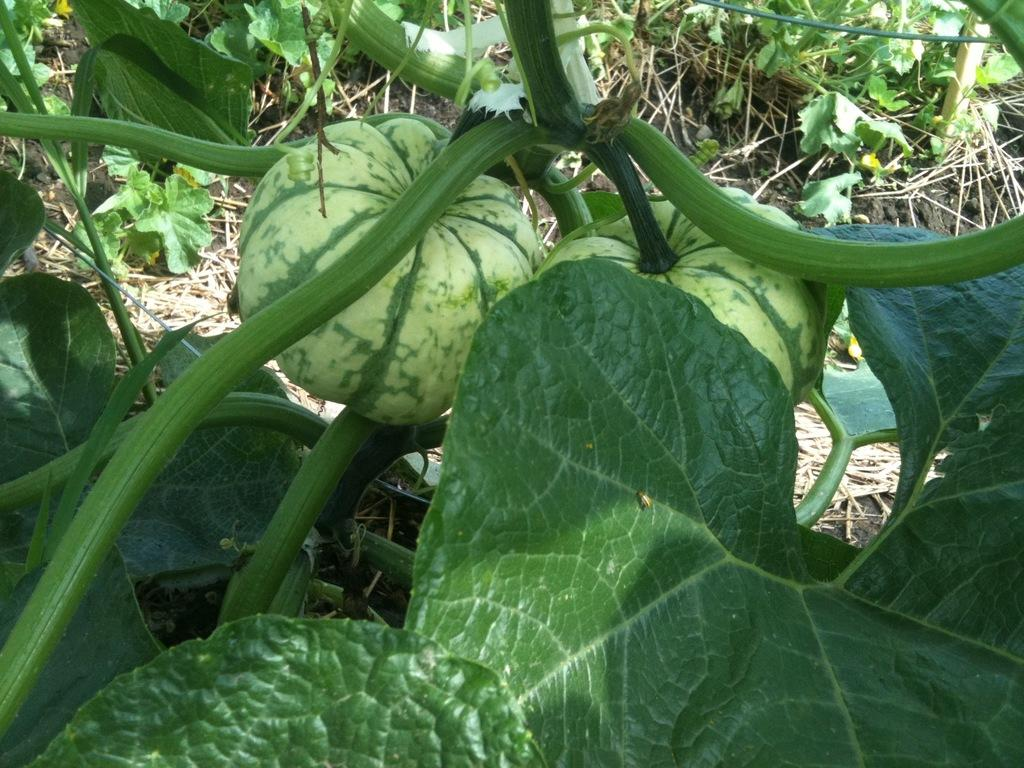What type of plants can be seen in the image? There are pumpkin plants in the image. Where are the pumpkin plants located? The pumpkin plants are on the land. How many fingers can be seen on the pumpkin plants in the image? There are no fingers present on the pumpkin plants in the image, as they are plants and not human beings. 